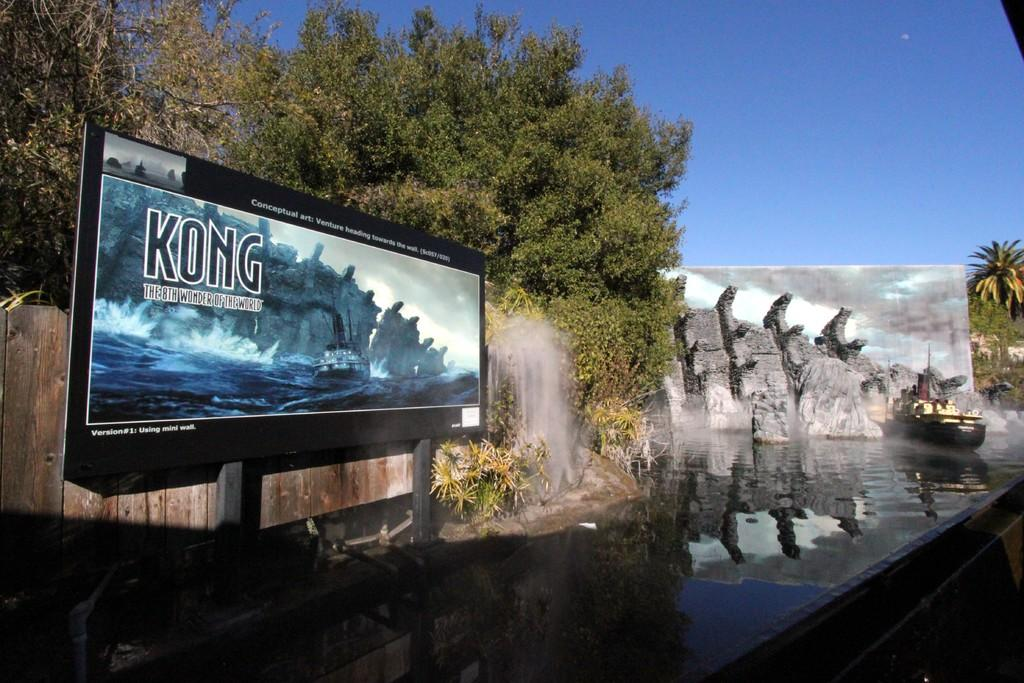<image>
Create a compact narrative representing the image presented. A billboard advertisement for the water ride Kong 